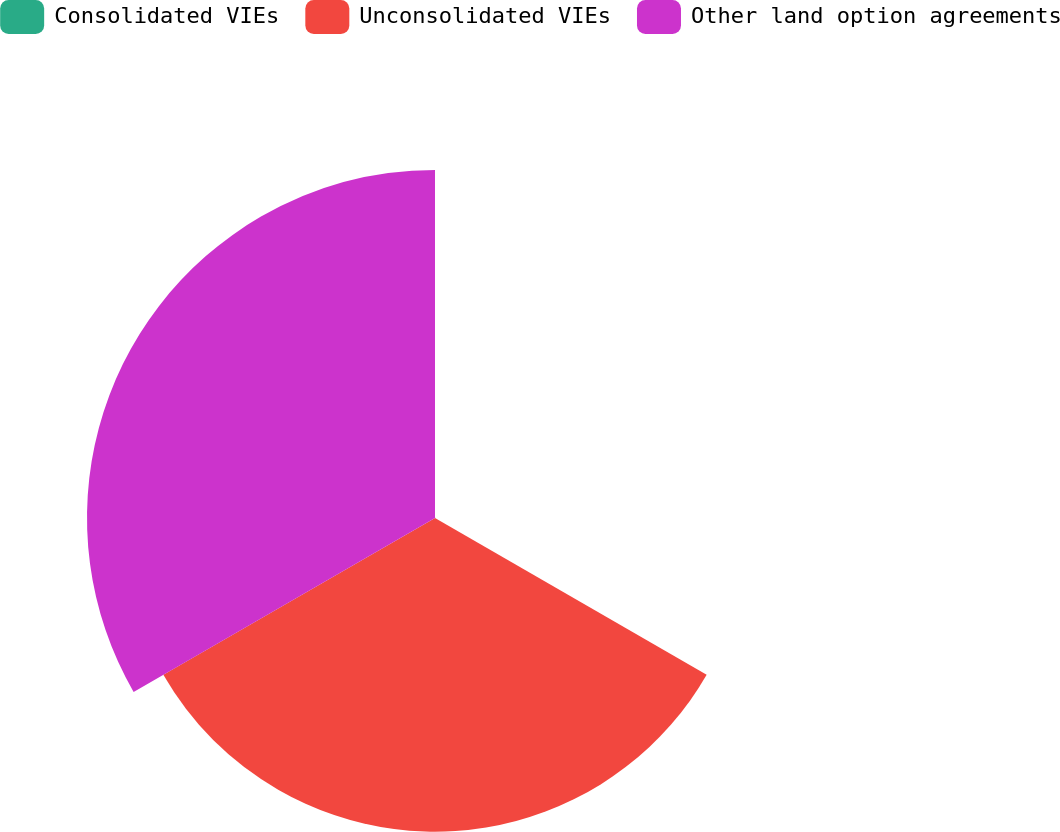Convert chart. <chart><loc_0><loc_0><loc_500><loc_500><pie_chart><fcel>Consolidated VIEs<fcel>Unconsolidated VIEs<fcel>Other land option agreements<nl><fcel>0.07%<fcel>47.37%<fcel>52.55%<nl></chart> 